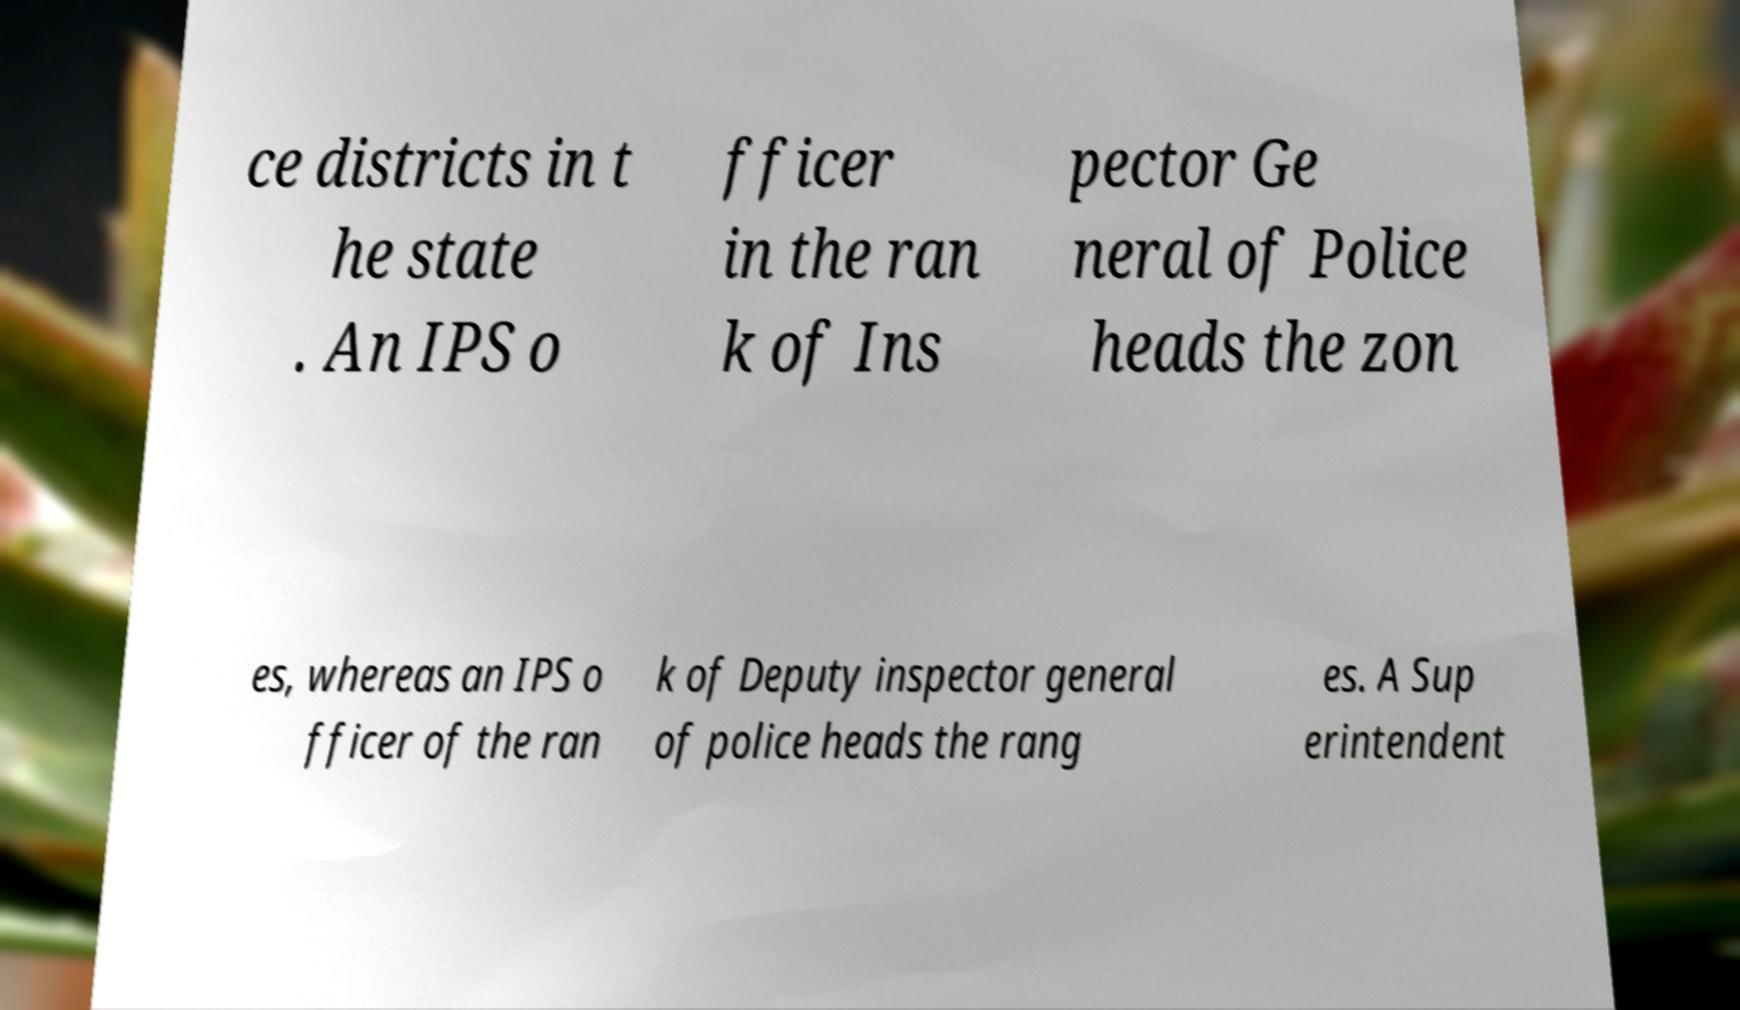Can you accurately transcribe the text from the provided image for me? ce districts in t he state . An IPS o fficer in the ran k of Ins pector Ge neral of Police heads the zon es, whereas an IPS o fficer of the ran k of Deputy inspector general of police heads the rang es. A Sup erintendent 